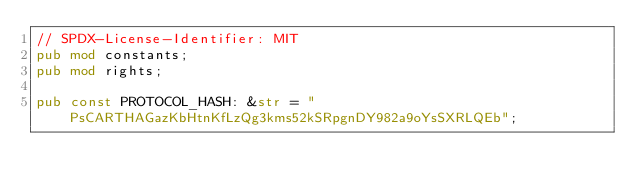<code> <loc_0><loc_0><loc_500><loc_500><_Rust_>// SPDX-License-Identifier: MIT
pub mod constants;
pub mod rights;

pub const PROTOCOL_HASH: &str = "PsCARTHAGazKbHtnKfLzQg3kms52kSRpgnDY982a9oYsSXRLQEb";
</code> 